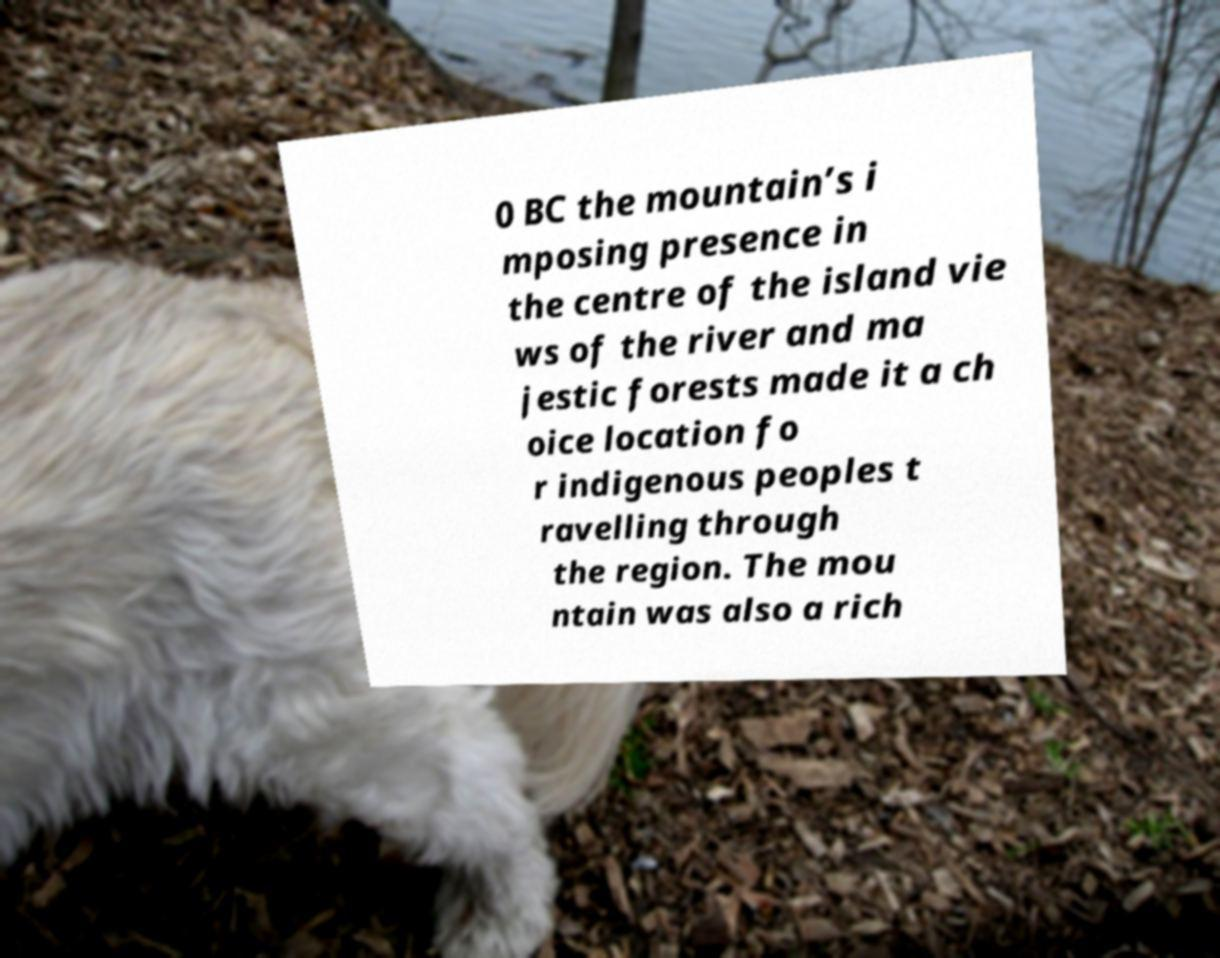What messages or text are displayed in this image? I need them in a readable, typed format. 0 BC the mountain’s i mposing presence in the centre of the island vie ws of the river and ma jestic forests made it a ch oice location fo r indigenous peoples t ravelling through the region. The mou ntain was also a rich 